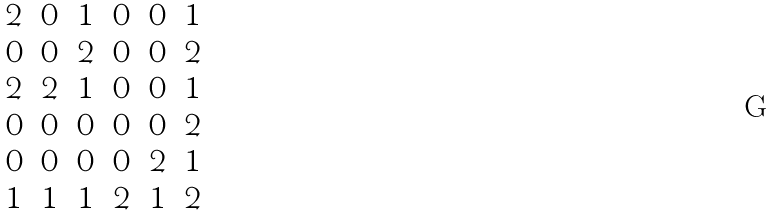Convert formula to latex. <formula><loc_0><loc_0><loc_500><loc_500>\begin{matrix} 2 & 0 & 1 & 0 & 0 & 1 \\ 0 & 0 & 2 & 0 & 0 & 2 \\ 2 & 2 & 1 & 0 & 0 & 1 \\ 0 & 0 & 0 & 0 & 0 & 2 \\ 0 & 0 & 0 & 0 & 2 & 1 \\ 1 & 1 & 1 & 2 & 1 & 2 \end{matrix}</formula> 